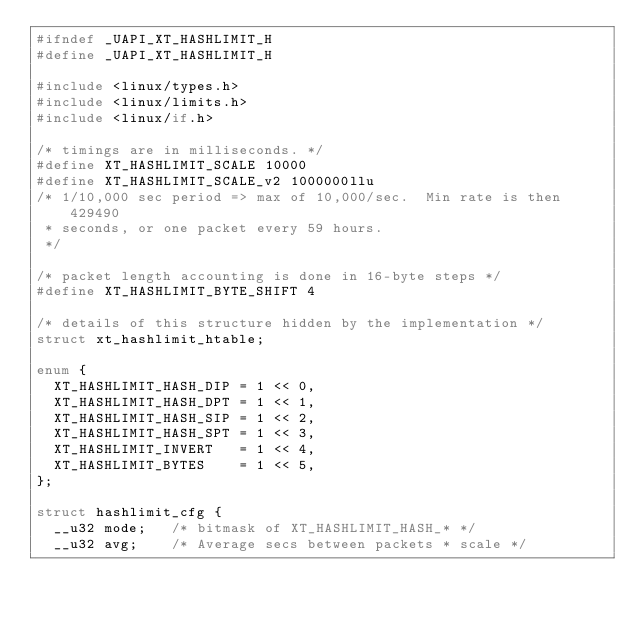Convert code to text. <code><loc_0><loc_0><loc_500><loc_500><_C_>#ifndef _UAPI_XT_HASHLIMIT_H
#define _UAPI_XT_HASHLIMIT_H

#include <linux/types.h>
#include <linux/limits.h>
#include <linux/if.h>

/* timings are in milliseconds. */
#define XT_HASHLIMIT_SCALE 10000
#define XT_HASHLIMIT_SCALE_v2 1000000llu
/* 1/10,000 sec period => max of 10,000/sec.  Min rate is then 429490
 * seconds, or one packet every 59 hours.
 */

/* packet length accounting is done in 16-byte steps */
#define XT_HASHLIMIT_BYTE_SHIFT 4

/* details of this structure hidden by the implementation */
struct xt_hashlimit_htable;

enum {
	XT_HASHLIMIT_HASH_DIP = 1 << 0,
	XT_HASHLIMIT_HASH_DPT = 1 << 1,
	XT_HASHLIMIT_HASH_SIP = 1 << 2,
	XT_HASHLIMIT_HASH_SPT = 1 << 3,
	XT_HASHLIMIT_INVERT   = 1 << 4,
	XT_HASHLIMIT_BYTES    = 1 << 5,
};

struct hashlimit_cfg {
	__u32 mode;	  /* bitmask of XT_HASHLIMIT_HASH_* */
	__u32 avg;    /* Average secs between packets * scale */</code> 